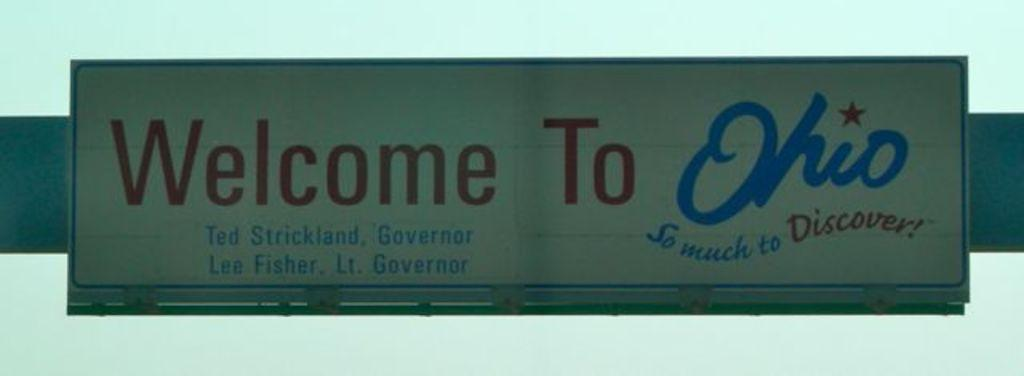<image>
Render a clear and concise summary of the photo. A red white and blue billboard bears the message WELCOME TO OHIO! 